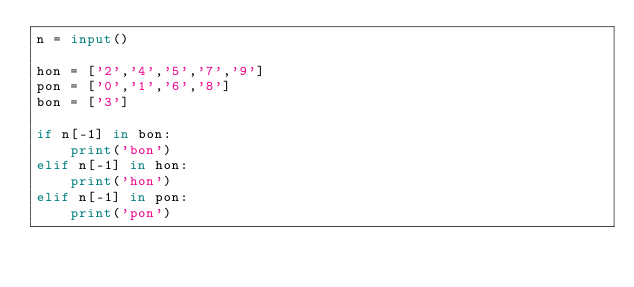<code> <loc_0><loc_0><loc_500><loc_500><_Python_>n = input()

hon = ['2','4','5','7','9']
pon = ['0','1','6','8']
bon = ['3']

if n[-1] in bon:
    print('bon')
elif n[-1] in hon:
    print('hon')
elif n[-1] in pon:
    print('pon')
</code> 